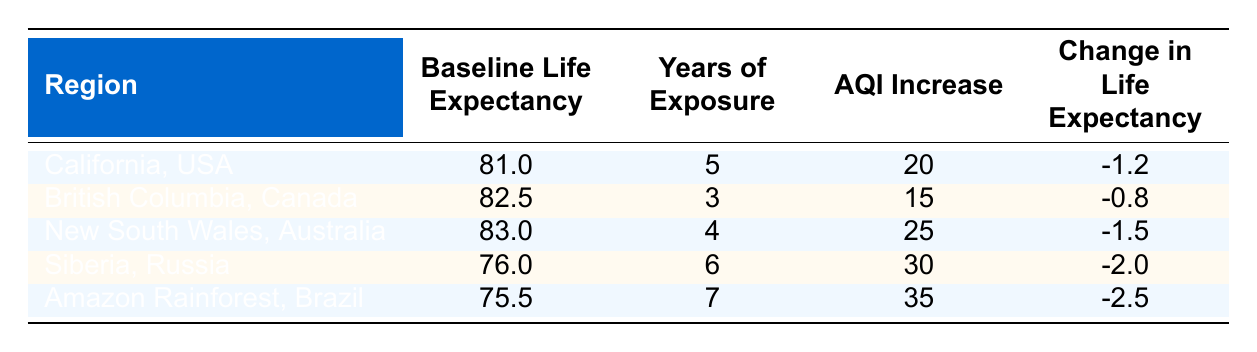What is the baseline life expectancy in California, USA? The table lists the baseline life expectancy for California, USA directly in the corresponding row, which is 81.0 years.
Answer: 81.0 Which region has the highest change in life expectancy due to air quality deterioration? By comparing the 'Change in Life Expectancy' values from each region, it is clear that the Amazon Rainforest, Brazil has the highest negative change at -2.5.
Answer: Amazon Rainforest, Brazil What is the average air quality index (AQI) increase across all five regions? First, we sum the AQI increase values: 20 + 15 + 25 + 30 + 35 = 125. Then, we divide by the number of regions (5): 125 / 5 = 25.
Answer: 25 Is the change in life expectancy for British Columbia, Canada greater than that of New South Wales, Australia? The change in life expectancy for British Columbia is -0.8 and for New South Wales, it is -1.5. Since -0.8 is greater than -1.5, the statement is true.
Answer: Yes How much lower is the baseline life expectancy in Siberia, Russia compared to California, USA? The baseline life expectancy in California is 81.0 and in Siberia, it is 76.0. The difference is 81.0 - 76.0 = 5.0 years.
Answer: 5.0 What is the relationship between years of exposure and change in life expectancy in this data? Examining the correlation, regions with higher years of exposure do not consistently show a greater negative change in life expectancy, indicating the relationship may not be straightforward. For instance, California has 5 years of exposure but a smaller change compared to the Amazon with 7 years and a larger change.
Answer: No clear relationship Which region experienced the longest exposure to wildfire impacts? By examining the 'Years of Exposure' column, we see that the Amazon Rainforest, Brazil had the longest exposure at 7 years.
Answer: Amazon Rainforest, Brazil Is there any region where the baseline life expectancy is over 80 years but has a change in life expectancy of more than -2.0? Looking at the baseline life expectancy for New South Wales (83.0, -1.5) and British Columbia (82.5, -0.8), neither has a change in life expectancy below -2.0, therefore the answer is no.
Answer: No 